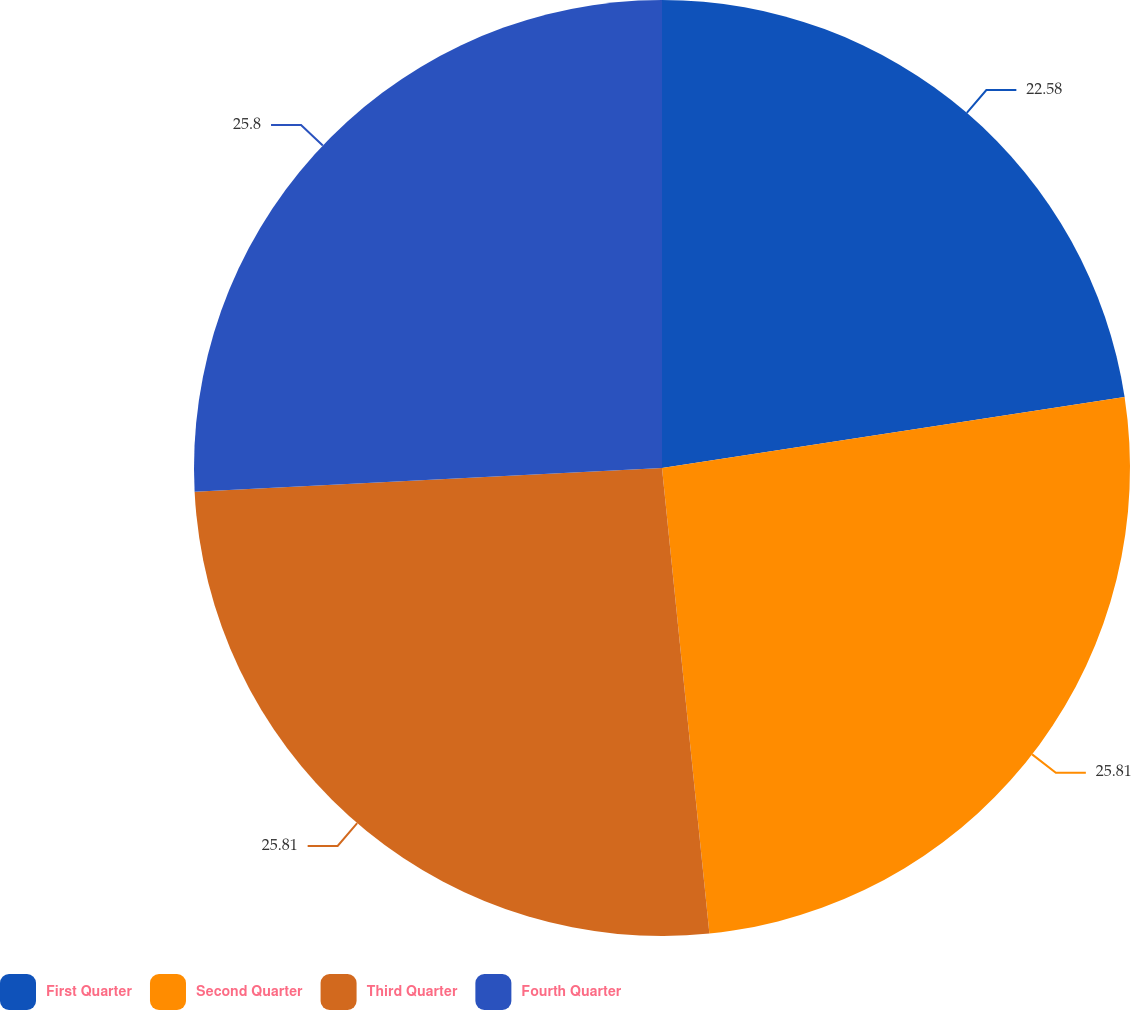Convert chart to OTSL. <chart><loc_0><loc_0><loc_500><loc_500><pie_chart><fcel>First Quarter<fcel>Second Quarter<fcel>Third Quarter<fcel>Fourth Quarter<nl><fcel>22.58%<fcel>25.81%<fcel>25.81%<fcel>25.81%<nl></chart> 